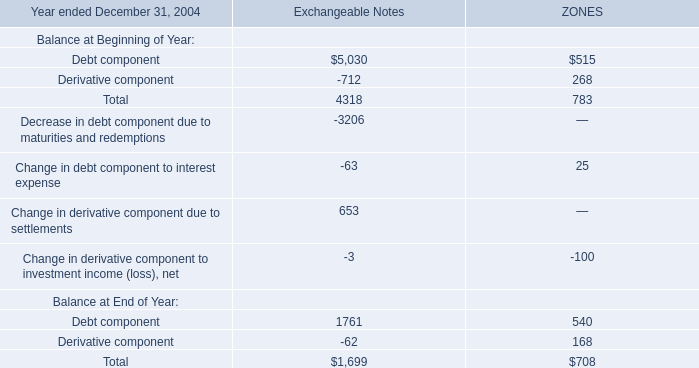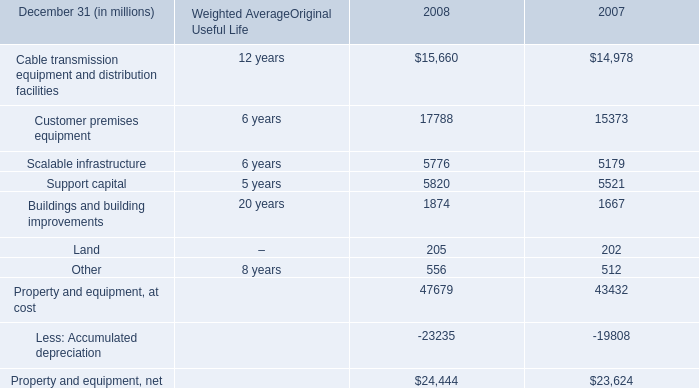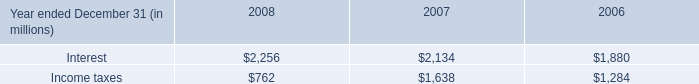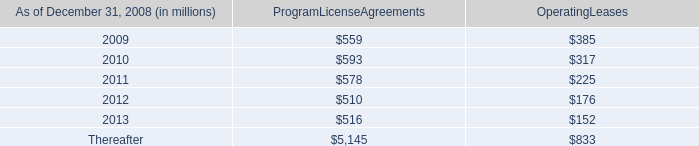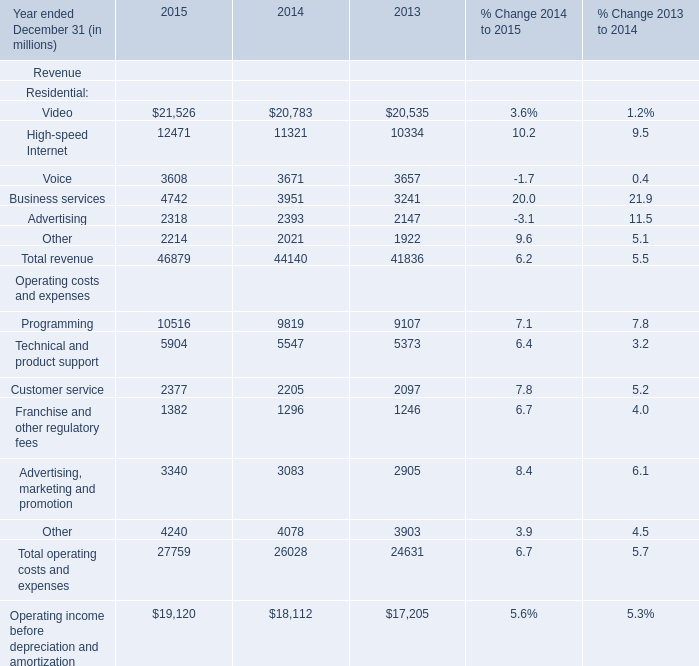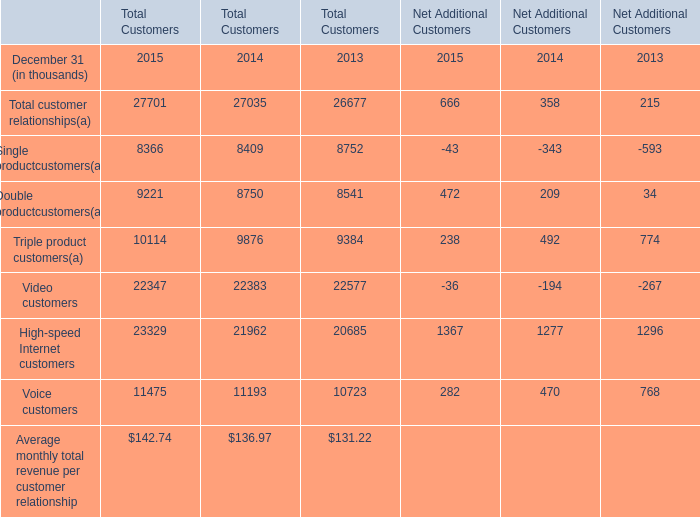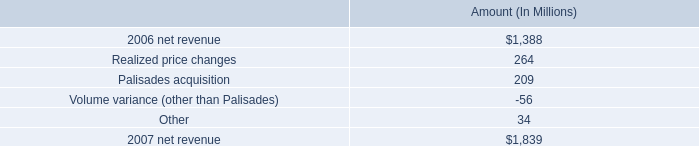What do all Net Additional Customers sum up in 2015, excluding Voice customers and High-speed Internet customers? (in thousand) 
Computations: ((((666 - 43) + 472) + 238) - 36)
Answer: 1297.0. 